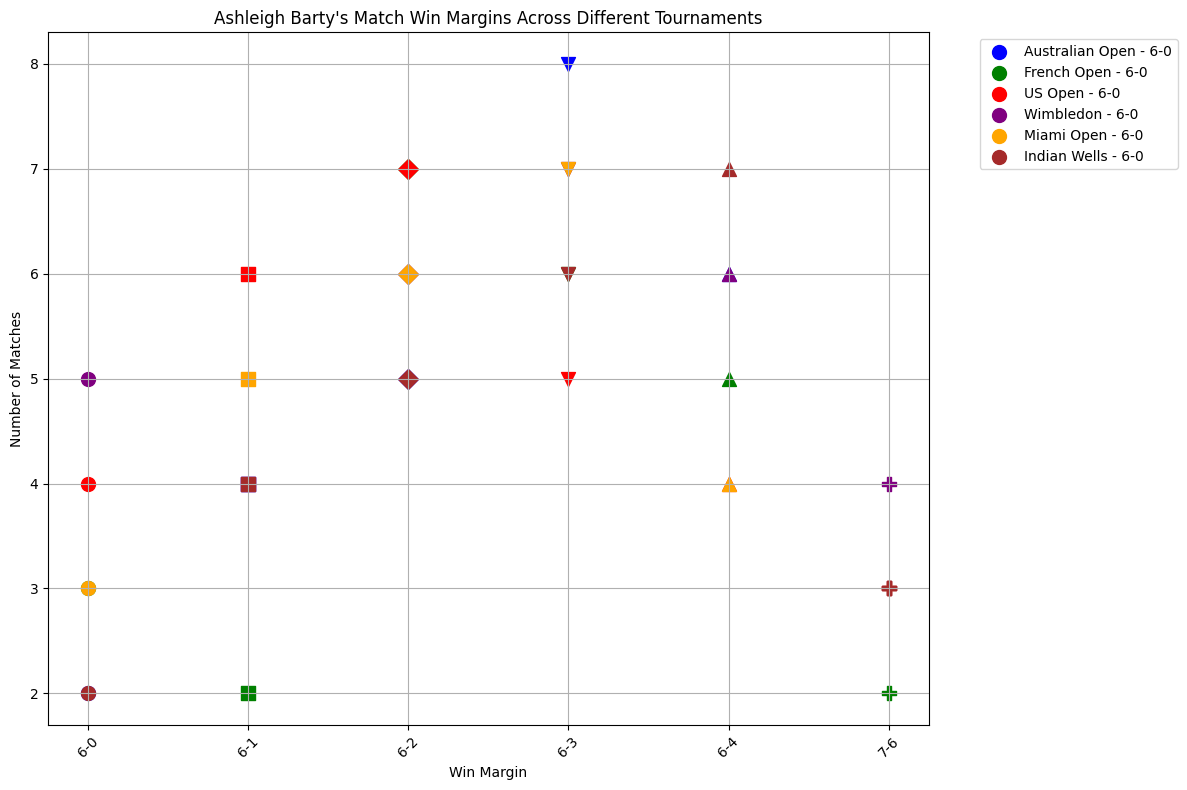Which tournament has the highest number of matches with a 6-0 win margin? Look at the clusters for 6-0 win margins and compare the heights of the points; Wimbledon has the highest point for matches with a 6-0 win margin.
Answer: Wimbledon In which tournament did Ashleigh Barty have the most matches with a 6-3 win margin? Locate the 6-3 win margin points and compare the number of matches (heights) across different tournaments; Australian Open has the highest point for 6-3 win margins.
Answer: Australian Open What is the total number of matches Barty won with a 6-2 win margin across all tournaments? Sum the number of matches with a 6-2 win margin for all tournaments; (5 from Australian Open) + (7 from French Open) + (7 from US Open) + (6 from Wimbledon) + (6 from Miami Open) + (5 from Indian Wells) = 36.
Answer: 36 Which tournament has the least number of 7-6 win margin matches? Compare the points at the 7-6 win margin across all tournaments; both French Open and Indian Wells have equally least points.
Answer: French Open, Indian Wells How many more matches did Barty win with a 6-1 win margin in the US Open compared to Indian Wells? Compare the number of matches with a 6-1 win margin in US Open and Indian Wells; (US Open: 6) - (Indian Wells: 4) = 2.
Answer: 2 Which tournament has the most even spread of win margins (seeing points scattered at more varying heights)? Identify the tournament with the widest distribution across different win margins; Wimbledon and US Open appear to have well-distributed win margin heights.
Answer: Wimbledon, US Open For which win margin did Barty consistently have a similar number of wins across multiple tournaments? Identify win margins with clusters of points having similar heights across tournaments; 6-2 has similar counts across multiple tournaments.
Answer: 6-2 What is the largest difference in the number of matches won with a 6-4 margin between two tournaments? Find the maximum and minimum number of matches won with a 6-4 margin and calculate the difference; (7 from Indian Wells) - (4 from Miami Open) = 3.
Answer: 3 Which tournament has a visually distinct color and also shows a sizable number of matches won by the 6-2 margin? Identify clusters with a specific visual color and height of points at the 6-2 win margin; French Open (green) and US Open (red) have significant numbers.
Answer: French Open, US Open 